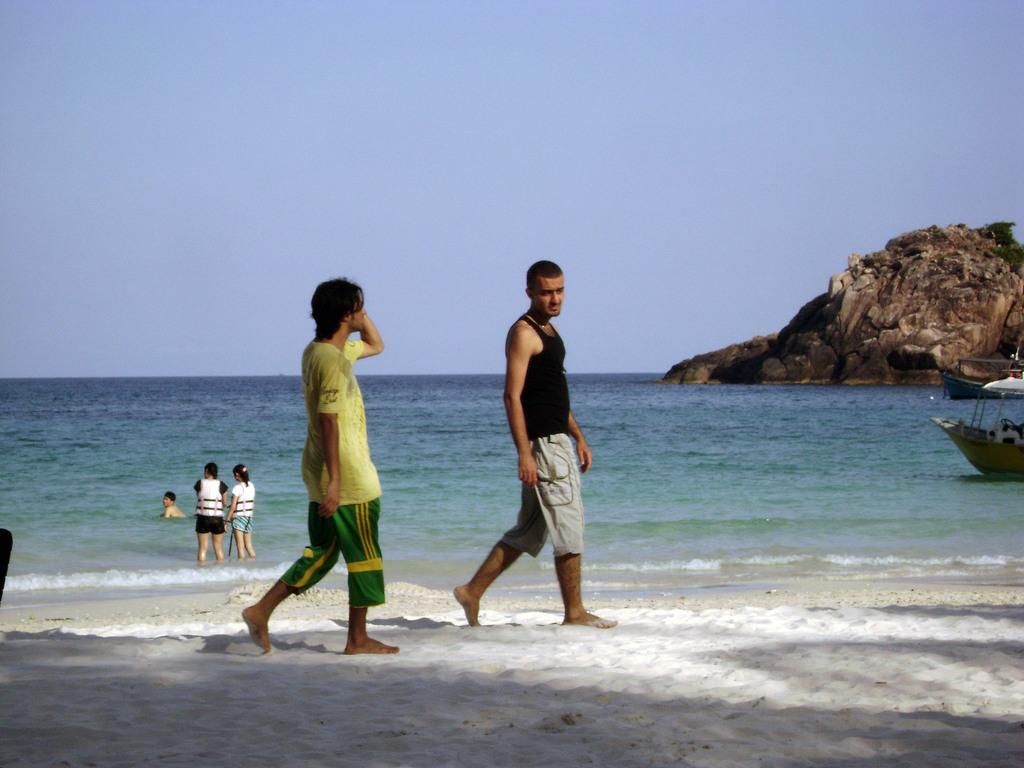What are the two people in the image doing? The two people in the image are walking on the sand. What can be seen above the water in the image? Boats are visible above the water. Are there any people near the boats? Yes, people are present near the boats. What is visible in the distance in the image? There is a rock visible in the distance. What is visible in the background of the image? The sky is visible in the background of the image. What type of brass instrument is being played by the people near the boats? There is no brass instrument present in the image; the people near the boats are not playing any musical instruments. What type of border is visible in the image? There is no border visible in the image; it is a natural scene with no man-made structures or boundaries. 